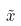Convert formula to latex. <formula><loc_0><loc_0><loc_500><loc_500>\tilde { x }</formula> 